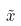Convert formula to latex. <formula><loc_0><loc_0><loc_500><loc_500>\tilde { x }</formula> 